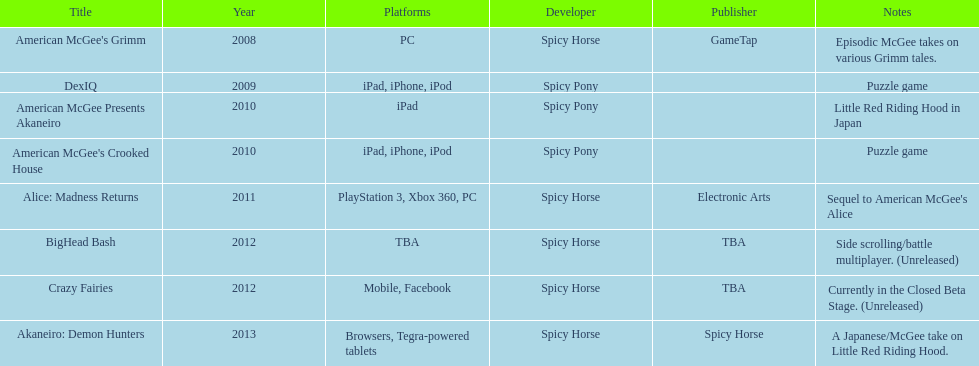In what year were two titles released altogether? 2010. 